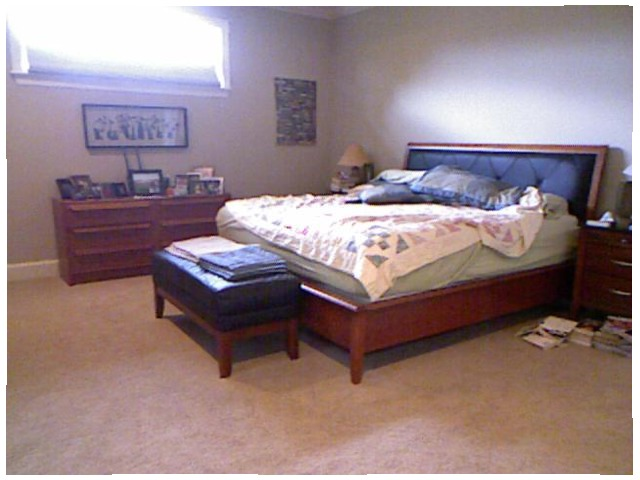<image>
Is there a books on the table? No. The books is not positioned on the table. They may be near each other, but the books is not supported by or resting on top of the table. 